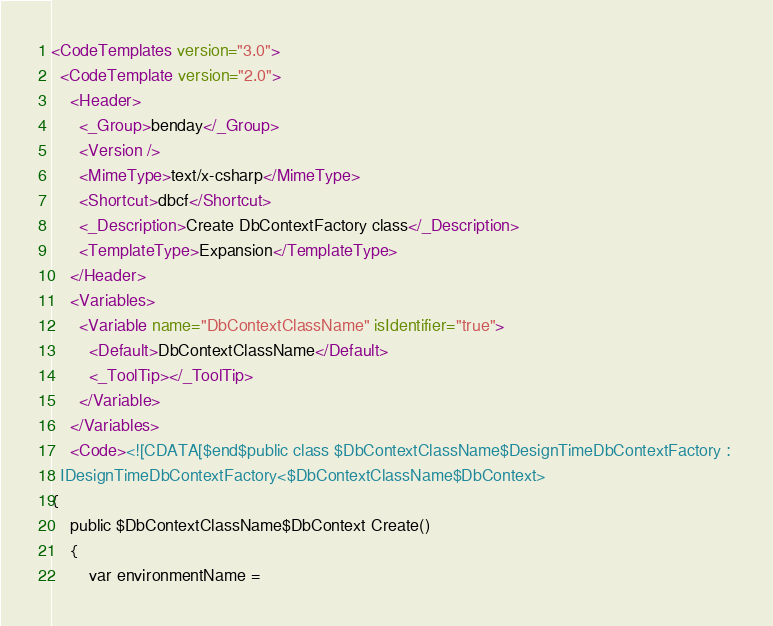<code> <loc_0><loc_0><loc_500><loc_500><_XML_><CodeTemplates version="3.0">
  <CodeTemplate version="2.0">
    <Header>
      <_Group>benday</_Group>
      <Version />
      <MimeType>text/x-csharp</MimeType>
      <Shortcut>dbcf</Shortcut>
      <_Description>Create DbContextFactory class</_Description>
      <TemplateType>Expansion</TemplateType>
    </Header>
    <Variables>
      <Variable name="DbContextClassName" isIdentifier="true">
        <Default>DbContextClassName</Default>
        <_ToolTip></_ToolTip>
      </Variable>
    </Variables>
    <Code><![CDATA[$end$public class $DbContextClassName$DesignTimeDbContextFactory : 
  IDesignTimeDbContextFactory<$DbContextClassName$DbContext>
{
    public $DbContextClassName$DbContext Create()
    {
        var environmentName = </code> 